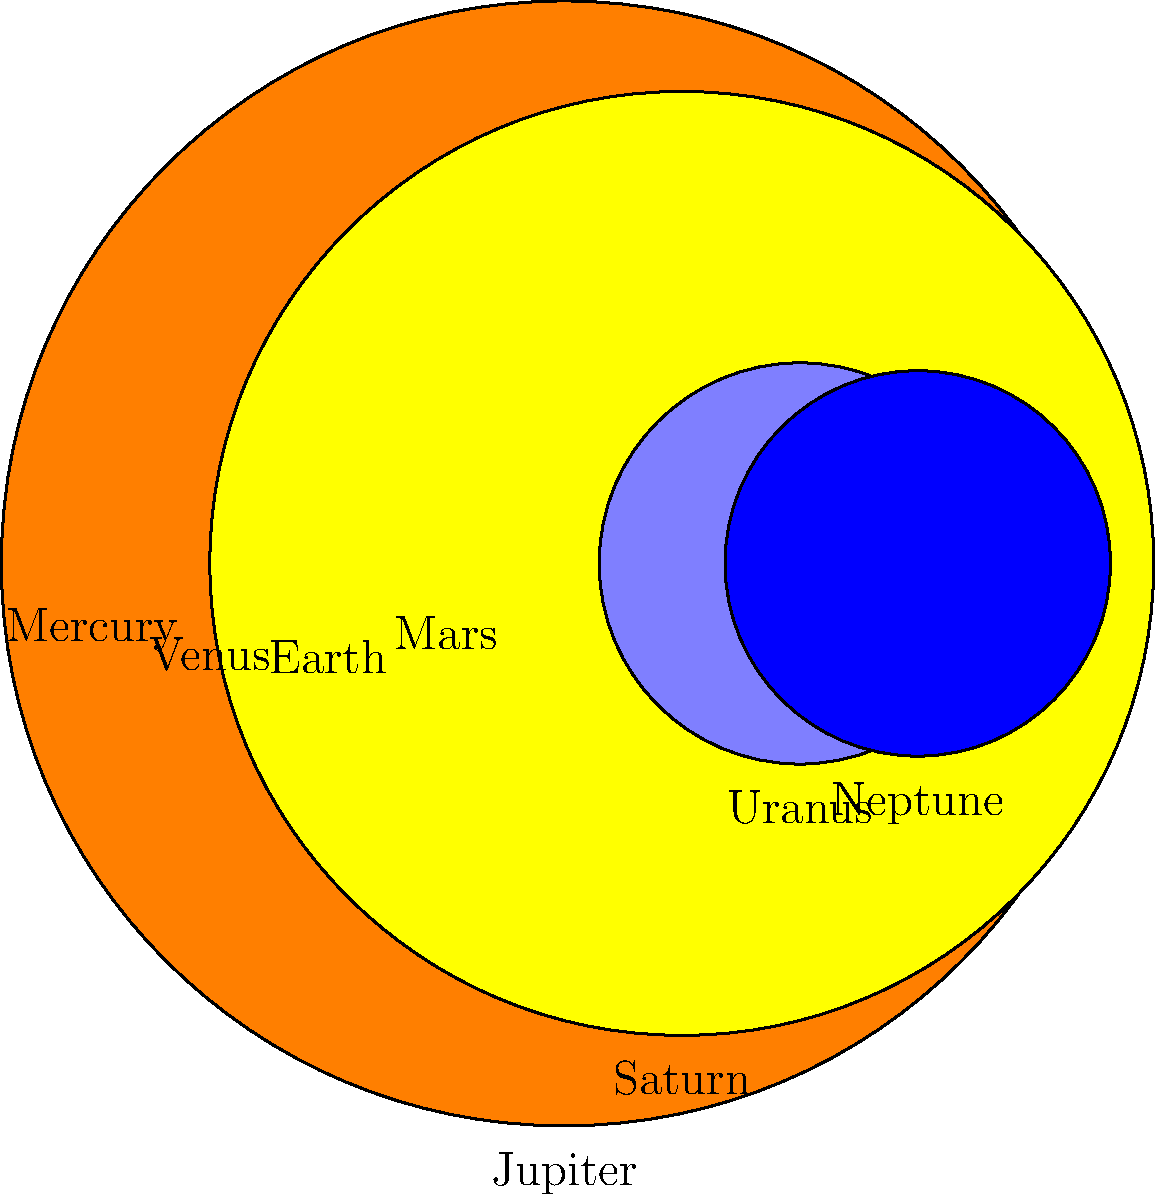As a strategist advising the CEO on market impact, you're presented with an artist's concept for a planetary size comparison exhibit. The image shows scaled representations of the eight planets in our solar system. If Jupiter's radius is set to 14.3 units in this scale, approximately how many times larger is Jupiter's radius compared to Earth's? To determine how many times larger Jupiter's radius is compared to Earth's, we need to follow these steps:

1. Identify the scaled radii for Jupiter and Earth from the image:
   Jupiter's radius = 14.3 units
   Earth's radius = 1.2756 units (the third circle from the left)

2. Set up a ratio of Jupiter's radius to Earth's radius:
   $\frac{\text{Jupiter's radius}}{\text{Earth's radius}} = \frac{14.3}{1.2756}$

3. Perform the division:
   $\frac{14.3}{1.2756} \approx 11.21$

4. Round to a reasonable number of significant figures:
   11.21 ≈ 11.2

Therefore, Jupiter's radius is approximately 11.2 times larger than Earth's radius in this scale.

This information could be valuable for the CEO to understand the potential impact of the exhibit, as it demonstrates the vast size differences between planets, which could be a key selling point or educational aspect of the artist's concept.
Answer: 11.2 times 